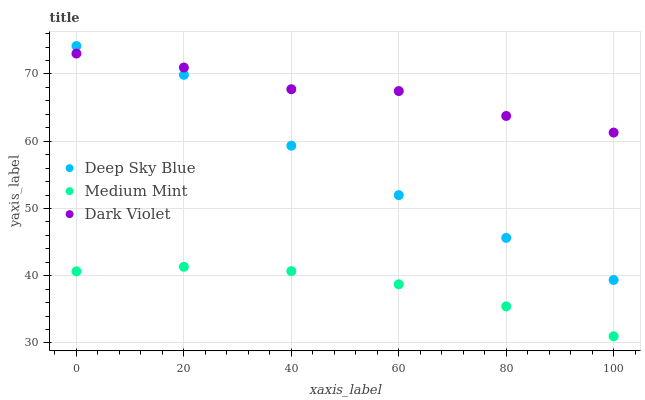Does Medium Mint have the minimum area under the curve?
Answer yes or no. Yes. Does Dark Violet have the maximum area under the curve?
Answer yes or no. Yes. Does Deep Sky Blue have the minimum area under the curve?
Answer yes or no. No. Does Deep Sky Blue have the maximum area under the curve?
Answer yes or no. No. Is Medium Mint the smoothest?
Answer yes or no. Yes. Is Deep Sky Blue the roughest?
Answer yes or no. Yes. Is Dark Violet the smoothest?
Answer yes or no. No. Is Dark Violet the roughest?
Answer yes or no. No. Does Medium Mint have the lowest value?
Answer yes or no. Yes. Does Deep Sky Blue have the lowest value?
Answer yes or no. No. Does Deep Sky Blue have the highest value?
Answer yes or no. Yes. Does Dark Violet have the highest value?
Answer yes or no. No. Is Medium Mint less than Dark Violet?
Answer yes or no. Yes. Is Deep Sky Blue greater than Medium Mint?
Answer yes or no. Yes. Does Deep Sky Blue intersect Dark Violet?
Answer yes or no. Yes. Is Deep Sky Blue less than Dark Violet?
Answer yes or no. No. Is Deep Sky Blue greater than Dark Violet?
Answer yes or no. No. Does Medium Mint intersect Dark Violet?
Answer yes or no. No. 